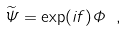Convert formula to latex. <formula><loc_0><loc_0><loc_500><loc_500>\widetilde { \Psi } = \exp ( i f ) \Phi \ ,</formula> 